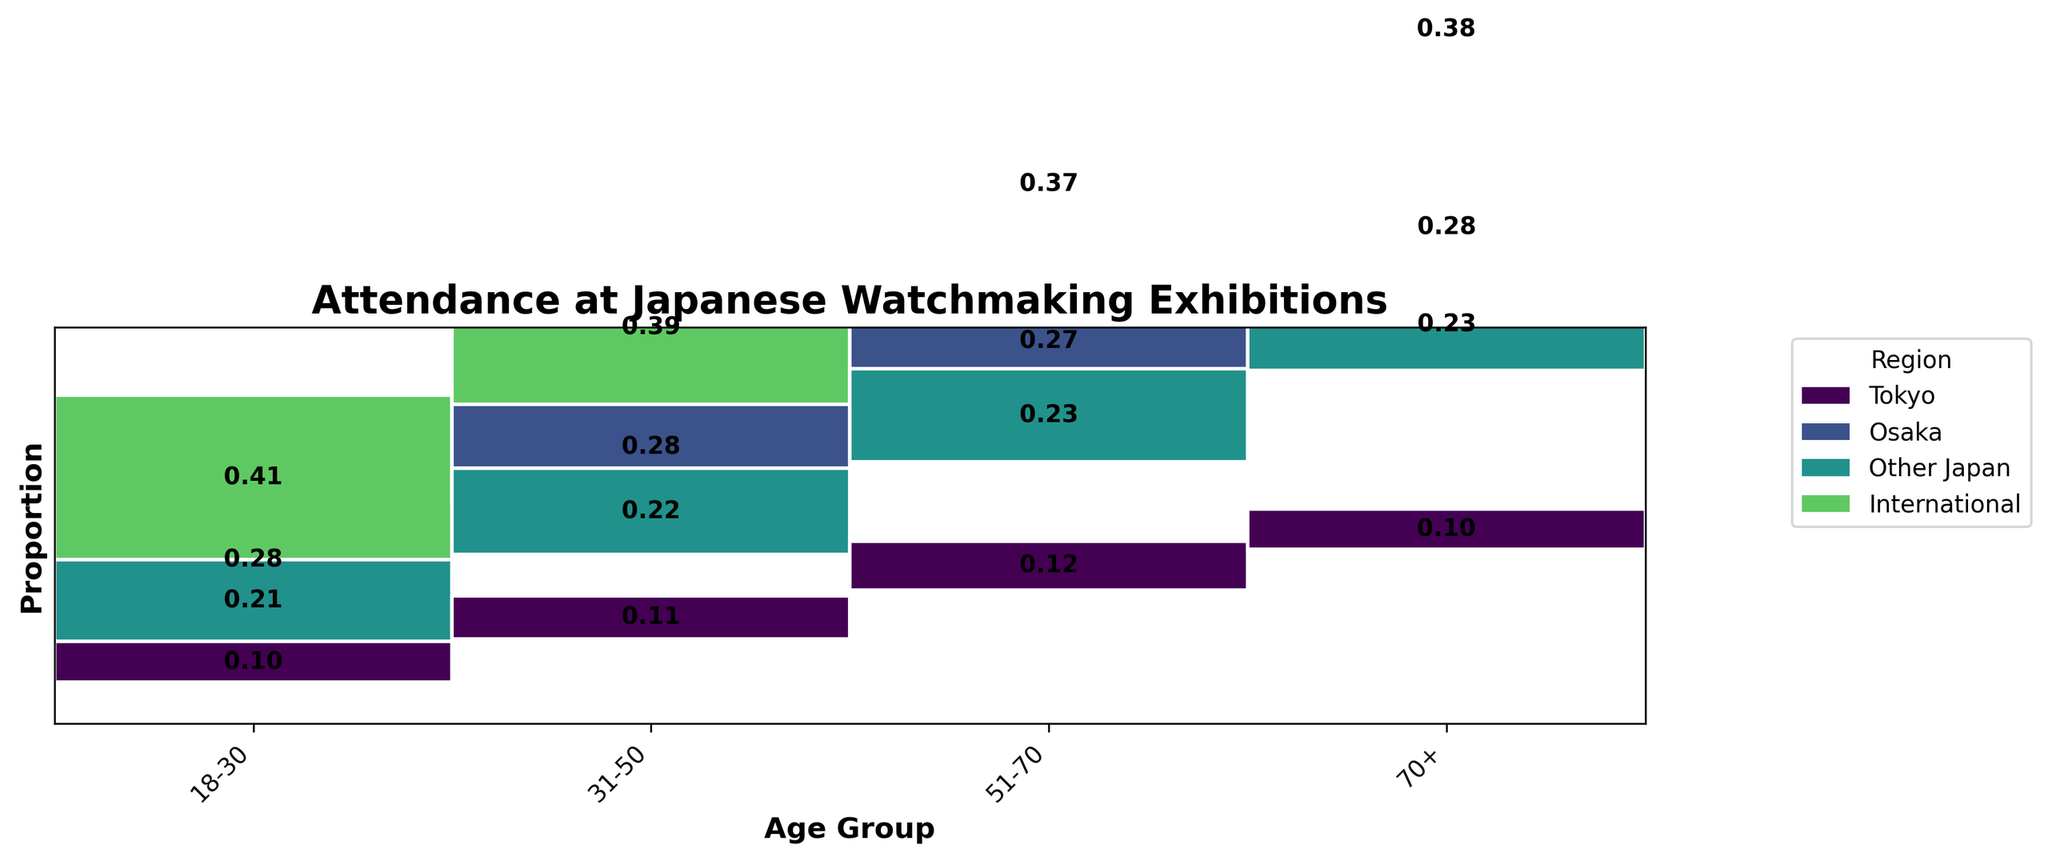what is the title of the figure? The title of the figure is located at the top center and provides a summary of what the figure represents.
Answer: Attendance at Japanese Watchmaking Exhibitions how many age groups are shown in the plot? The figure visually differentiates between age groups along the x-axis using distinct labels and positioning.
Answer: 4 which region has the highest attendance for the age group 31-50? By identifying the segment with the largest width within the age group 31-50 on the x-axis, one can determine the region with the highest attendance.
Answer: Tokyo what proportion of 70+ visitors come from international regions? Look at the height of the International segment within the 70+ age group and compare it to the total height for that age group.
Answer: 0.13 how does the attendance of people aged 51-70 from Osaka compare to those from Other Japan? Compare the heights of the segments for Osaka and Other Japan within the 51-70 age group to see which one is taller, indicating higher attendance.
Answer: Osaka has higher attendance which age group has the smallest proportion of international visitors? Compare the heights of the International segments across all age groups to identify the smallest one.
Answer: 18-30 which age group shows the most diverse regional attendance? Diverse regional attendance is indicated by segments of varying sizes for different regions within an age group. Analyze the heights of the segments for each age group.
Answer: 18-30 what is the difference in the proportion of Tokyo visitors between the age groups 31-50 and 51-70? Calculate the height of the Tokyo segment within each age group (31-50 and 51-70) and find the difference between these proportions.
Answer: 0.06 which region has the highest attendance overall? Sum the heights of the segments for each region across all age groups and identify the one with the total highest height.
Answer: Tokyo what is the average proportion of visitors from Osaka across all age groups? Calculate the sum of the proportions of visitors from Osaka for all age groups and divide it by the number of age groups (4).
Answer: 0.275 